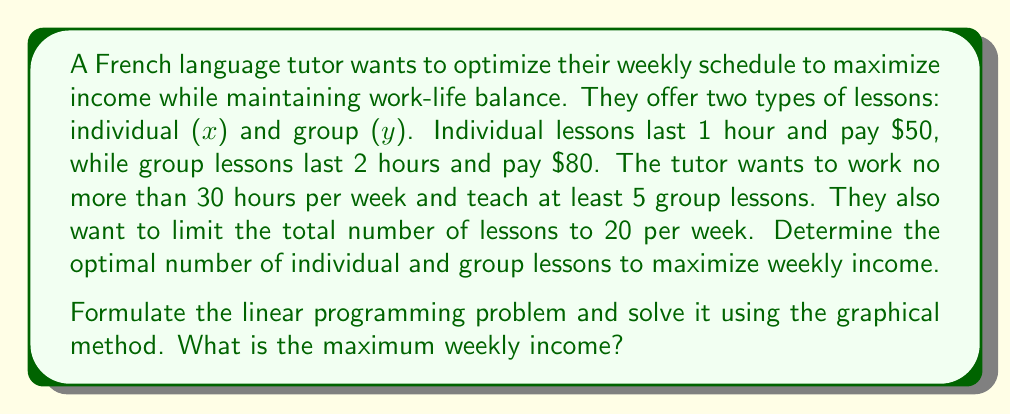What is the answer to this math problem? Let's approach this step-by-step:

1) First, we need to define our objective function and constraints:

   Objective function (to maximize): $f(x,y) = 50x + 80y$

   Constraints:
   - Time constraint: $x + 2y \leq 30$ (total hours ≤ 30)
   - Minimum group lessons: $y \geq 5$
   - Total lessons constraint: $x + y \leq 20$
   - Non-negativity: $x \geq 0$, $y \geq 0$

2) Now, let's graph these constraints:

   [asy]
   import geometry;

   size(200);
   
   xaxis("x", 0, 25, Arrow);
   yaxis("y", 0, 15, Arrow);

   draw((0,15)--(20,10), blue);
   draw((0,5)--(25,5), red);
   draw((30,0)--(0,15), green);

   label("$x+y=20$", (18,9), NE, blue);
   label("$y=5$", (23,5), E, red);
   label("$x+2y=30$", (25,2.5), SE, green);

   fill((0,5)--(0,15)--(10,10)--(20,5)--(0,5), lightgray);
   
   dot((0,15));
   dot((0,5));
   dot((10,10));
   dot((20,5));

   label("A(0,15)", (0,15), NW);
   label("B(0,5)", (0,5), W);
   label("C(10,10)", (10,10), NE);
   label("D(20,5)", (20,5), SE);
   [/asy]

3) The feasible region is the shaded area ABCD.

4) To find the optimal solution, we evaluate the objective function at each corner point:

   A(0,15): $f(0,15) = 50(0) + 80(15) = 1200$
   B(0,5): $f(0,5) = 50(0) + 80(5) = 400$
   C(10,10): $f(10,10) = 50(10) + 80(10) = 1300$
   D(20,5): $f(20,5) = 50(20) + 80(5) = 1400$

5) The maximum value occurs at point D(20,5), which represents 20 individual lessons and 5 group lessons per week.

6) The maximum weekly income is therefore $1400.
Answer: $1400 